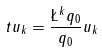Convert formula to latex. <formula><loc_0><loc_0><loc_500><loc_500>\ t u _ { k } = \frac { \L ^ { k } q _ { 0 } } { q _ { 0 } } u _ { k }</formula> 